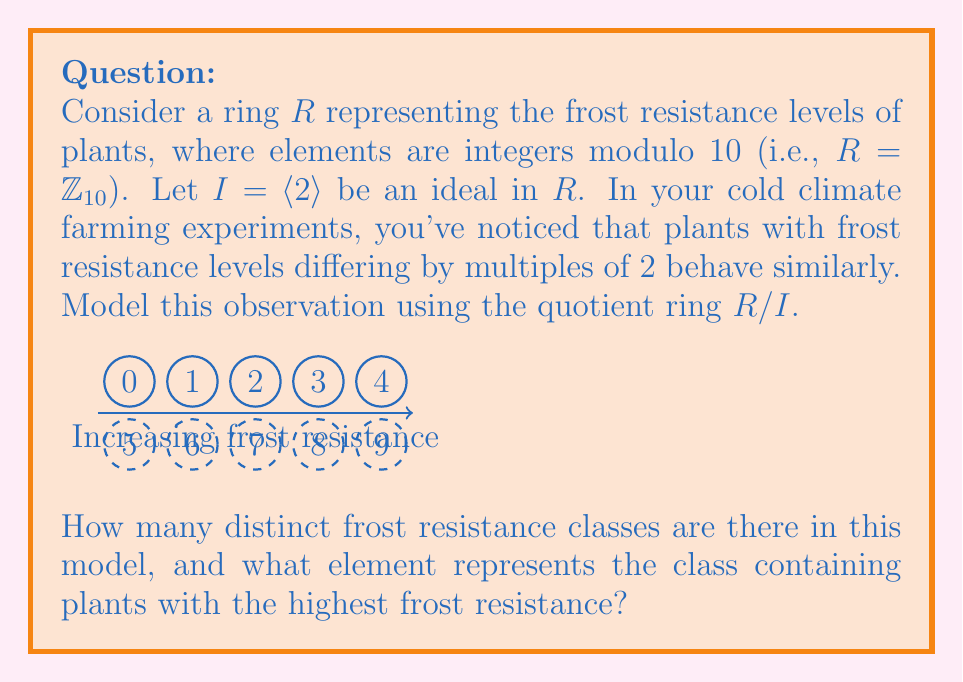Can you solve this math problem? Let's approach this step-by-step:

1) In the quotient ring $R/I$, two elements $a$ and $b$ are in the same equivalence class if and only if $a - b \in I$.

2) Since $I = \langle 2 \rangle$, this means $a$ and $b$ are in the same class if $a - b$ is a multiple of 2.

3) Let's list out the elements of $R/I$:
   $[0] = \{0, 2, 4, 6, 8\}$
   $[1] = \{1, 3, 5, 7, 9\}$

4) We can see that there are only two distinct classes in $R/I$: $[0]$ and $[1]$.

5) To determine which class represents the highest frost resistance, we need to consider the original ring $R = \mathbb{Z}_{10}$.

6) In $R$, 9 represents the highest frost resistance (as 10 ≡ 0 mod 10).

7) 9 belongs to the class $[1]$ in $R/I$.

Therefore, there are 2 distinct frost resistance classes in this model, and the class $[1]$ represents the plants with the highest frost resistance.
Answer: 2 classes; $[1]$ 